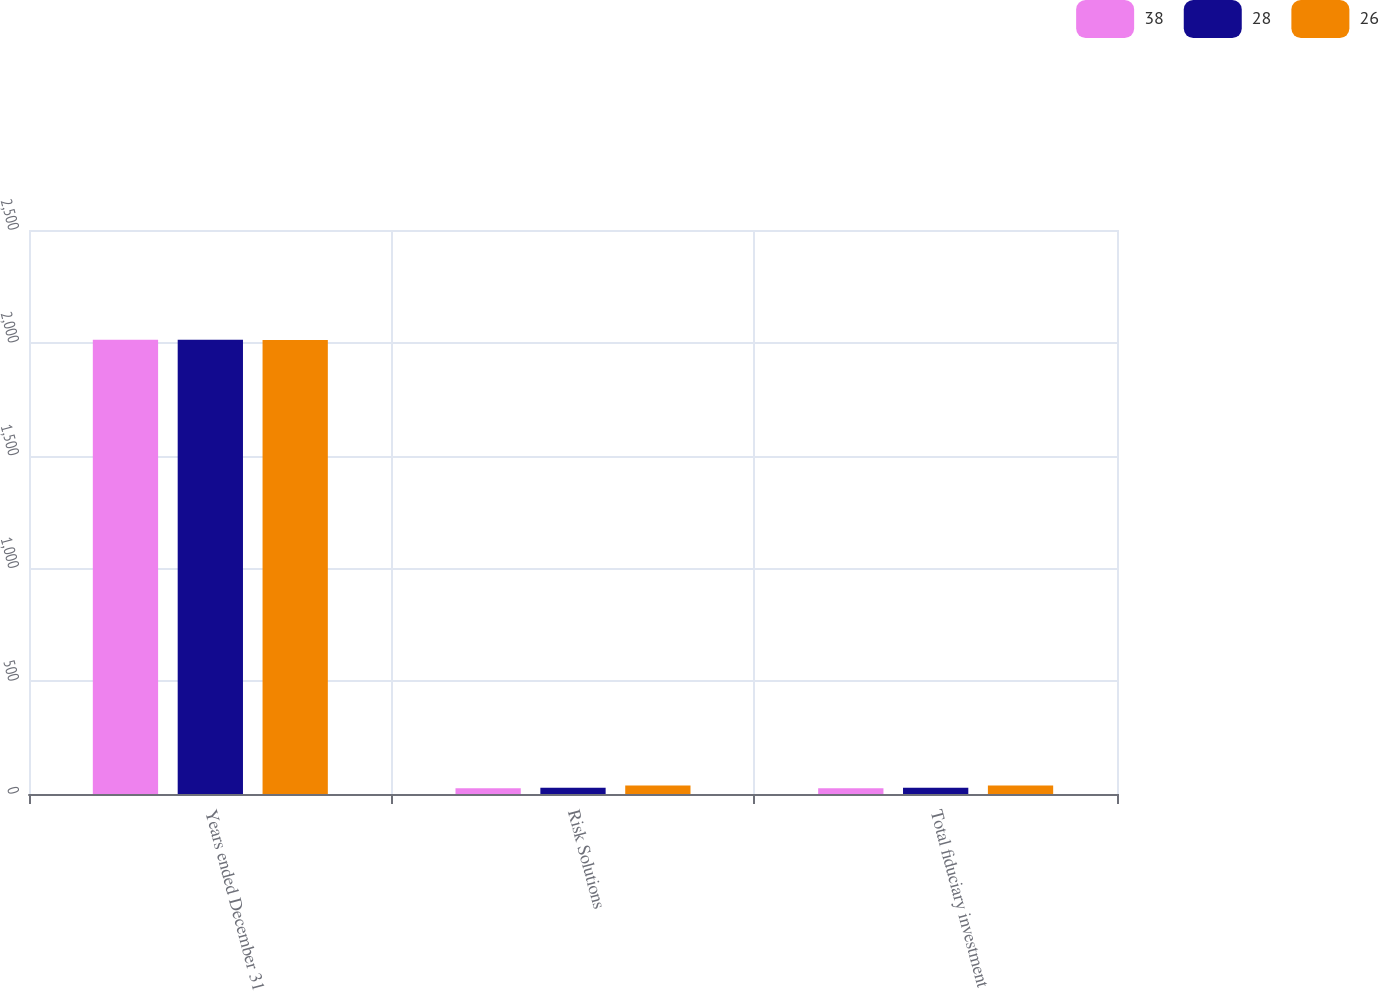Convert chart to OTSL. <chart><loc_0><loc_0><loc_500><loc_500><stacked_bar_chart><ecel><fcel>Years ended December 31<fcel>Risk Solutions<fcel>Total fiduciary investment<nl><fcel>38<fcel>2014<fcel>26<fcel>26<nl><fcel>28<fcel>2013<fcel>28<fcel>28<nl><fcel>26<fcel>2012<fcel>38<fcel>38<nl></chart> 